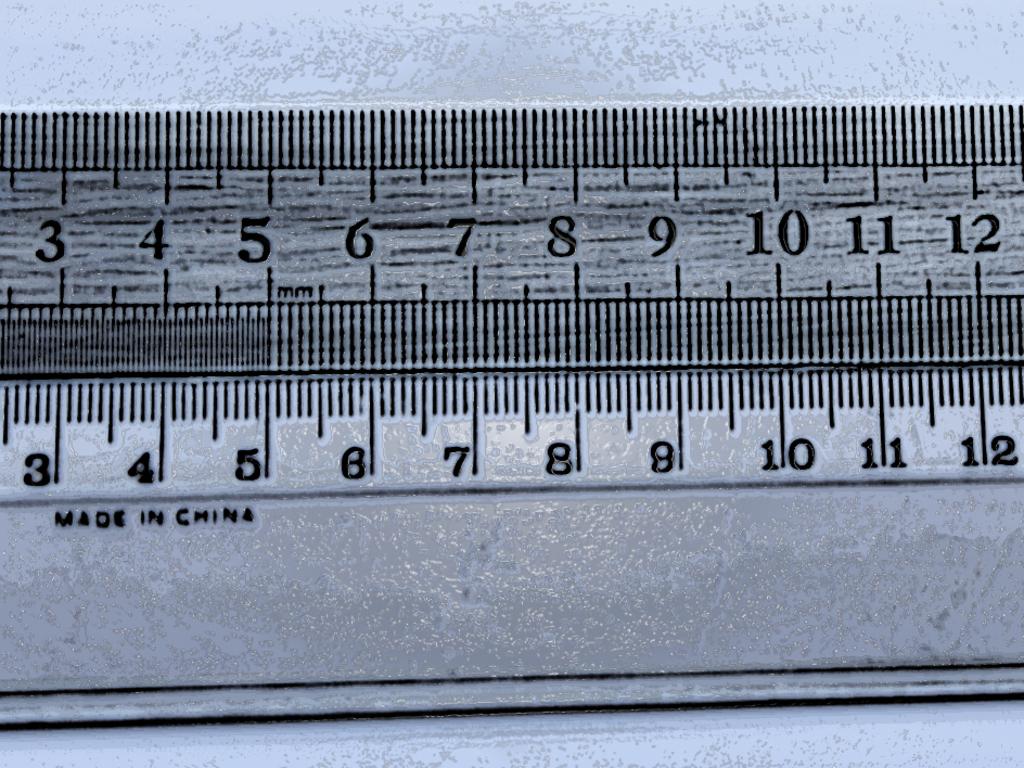Where was the ruler made?
Make the answer very short. China. What is the highest number?
Make the answer very short. 12. 